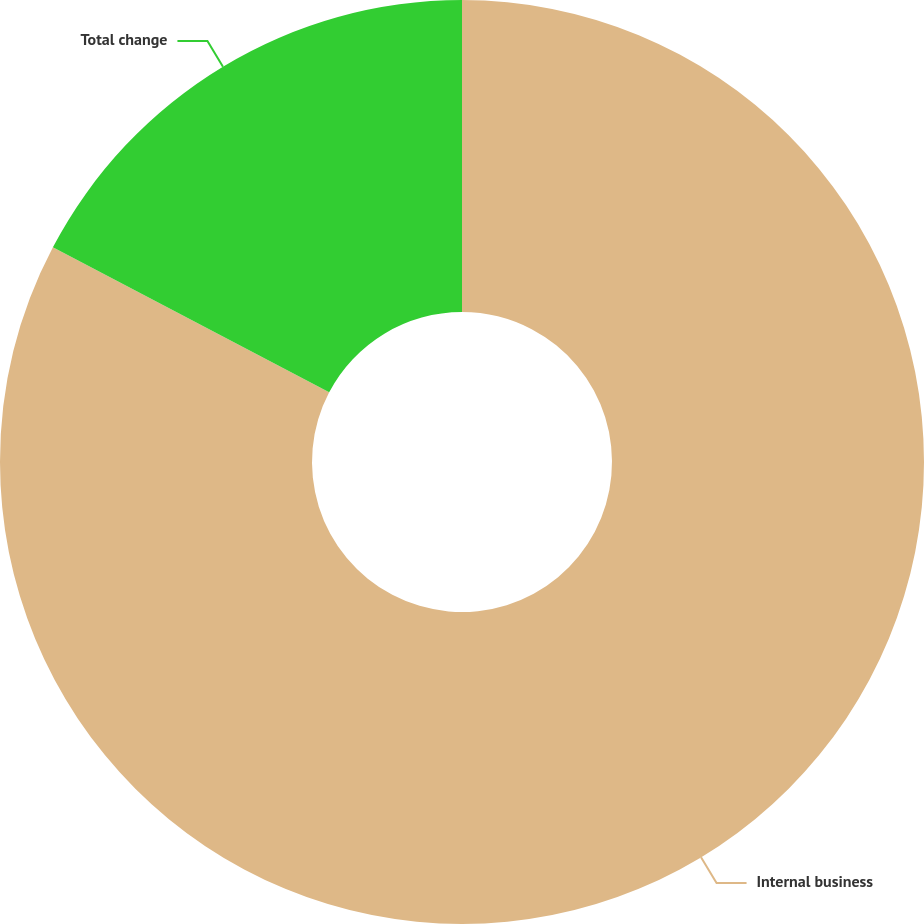Convert chart. <chart><loc_0><loc_0><loc_500><loc_500><pie_chart><fcel>Internal business<fcel>Total change<nl><fcel>82.69%<fcel>17.31%<nl></chart> 